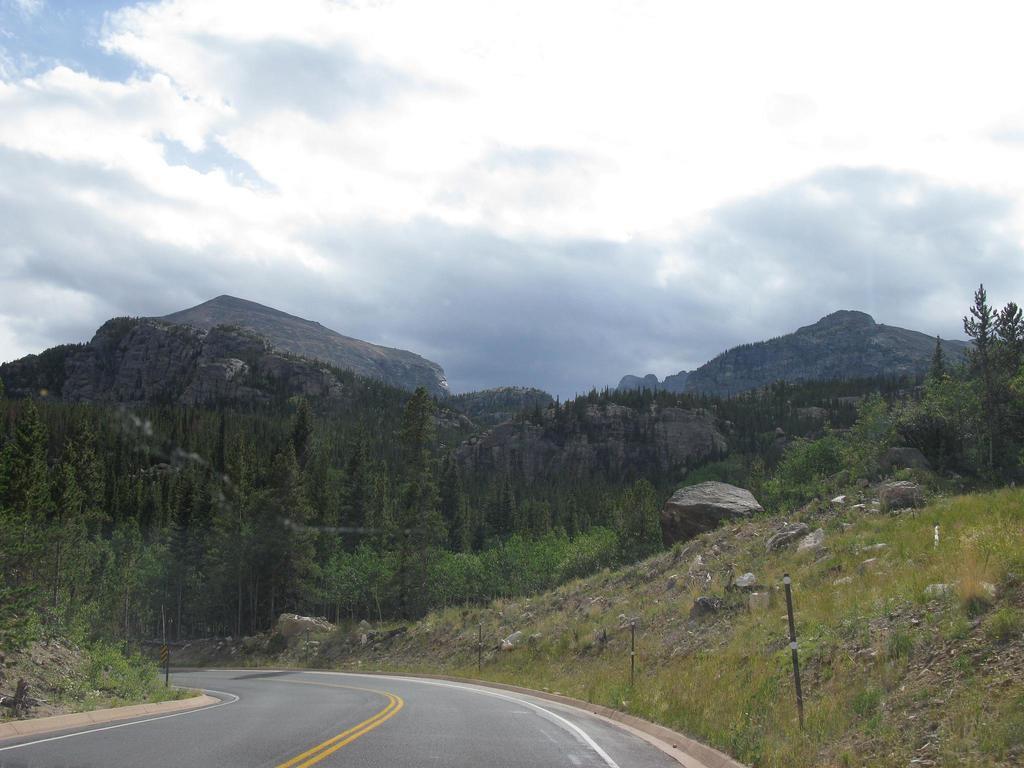In one or two sentences, can you explain what this image depicts? In this picture we can see a road, beside this road we can see some stones, grass, poles and in the background we can see mountains, trees, sky. 